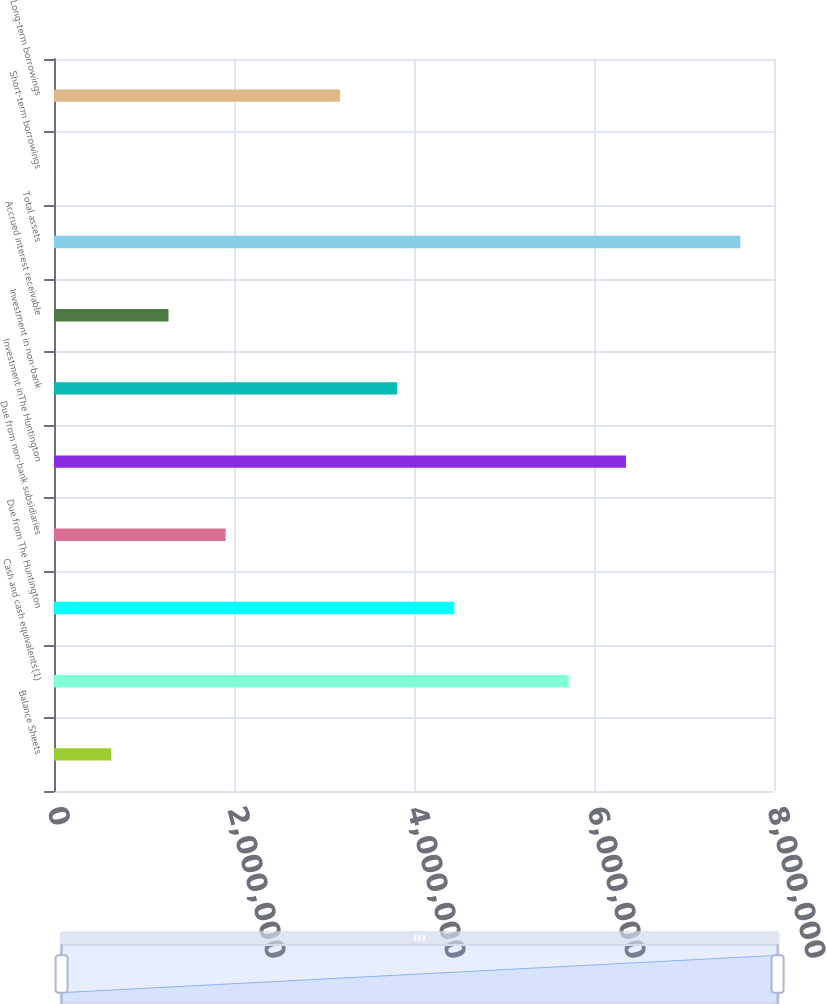Convert chart to OTSL. <chart><loc_0><loc_0><loc_500><loc_500><bar_chart><fcel>Balance Sheets<fcel>Cash and cash equivalents(1)<fcel>Due from The Huntington<fcel>Due from non-bank subsidiaries<fcel>Investment inThe Huntington<fcel>Investment in non-bank<fcel>Accrued interest receivable<fcel>Total assets<fcel>Short-term borrowings<fcel>Long-term borrowings<nl><fcel>636664<fcel>5.71965e+06<fcel>4.4489e+06<fcel>1.90741e+06<fcel>6.35502e+06<fcel>3.81353e+06<fcel>1.27204e+06<fcel>7.62576e+06<fcel>1291<fcel>3.17816e+06<nl></chart> 